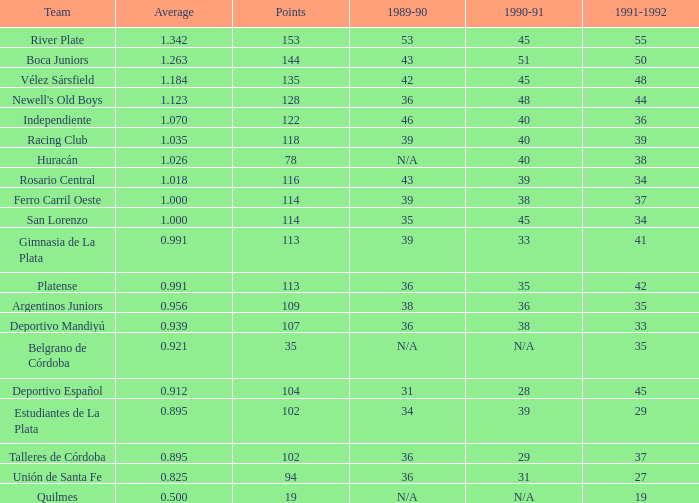How many instances of played have an average below 0.9390000000000001 and a 1990-91 figure of 28? 1.0. 